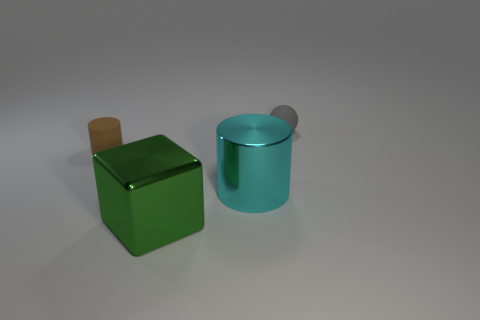How many things are things that are right of the large cyan shiny object or big purple cylinders?
Offer a very short reply. 1. Are there fewer brown rubber objects than small rubber things?
Offer a terse response. Yes. There is a brown thing that is the same material as the gray thing; what is its shape?
Make the answer very short. Cylinder. There is a large green metallic block; are there any gray objects on the right side of it?
Keep it short and to the point. Yes. Are there fewer objects that are behind the large cyan object than small purple things?
Give a very brief answer. No. What is the material of the big cyan object?
Offer a terse response. Metal. The matte ball has what color?
Provide a short and direct response. Gray. What is the color of the thing that is behind the large cylinder and to the right of the green shiny object?
Offer a terse response. Gray. Does the brown object have the same material as the big object in front of the large cyan metallic object?
Your response must be concise. No. What size is the object that is left of the metal object that is in front of the cyan shiny thing?
Keep it short and to the point. Small. 